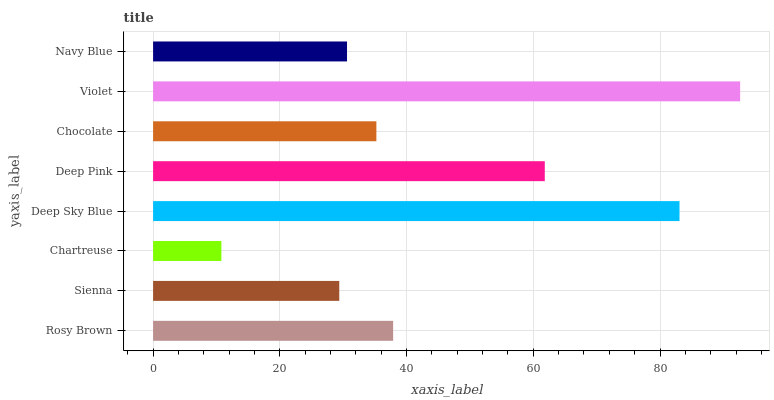Is Chartreuse the minimum?
Answer yes or no. Yes. Is Violet the maximum?
Answer yes or no. Yes. Is Sienna the minimum?
Answer yes or no. No. Is Sienna the maximum?
Answer yes or no. No. Is Rosy Brown greater than Sienna?
Answer yes or no. Yes. Is Sienna less than Rosy Brown?
Answer yes or no. Yes. Is Sienna greater than Rosy Brown?
Answer yes or no. No. Is Rosy Brown less than Sienna?
Answer yes or no. No. Is Rosy Brown the high median?
Answer yes or no. Yes. Is Chocolate the low median?
Answer yes or no. Yes. Is Violet the high median?
Answer yes or no. No. Is Chartreuse the low median?
Answer yes or no. No. 